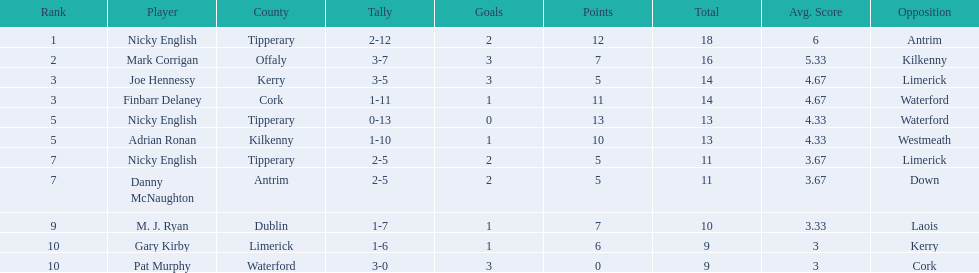Who are all the players? Nicky English, Mark Corrigan, Joe Hennessy, Finbarr Delaney, Nicky English, Adrian Ronan, Nicky English, Danny McNaughton, M. J. Ryan, Gary Kirby, Pat Murphy. How many points did they receive? 18, 16, 14, 14, 13, 13, 11, 11, 10, 9, 9. And which player received 10 points? M. J. Ryan. 